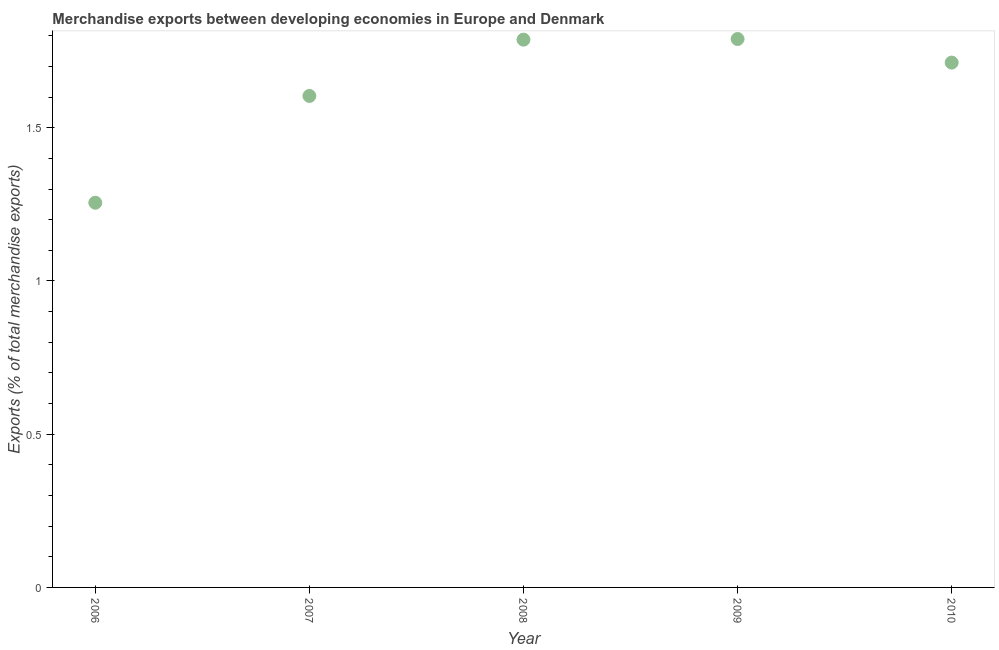What is the merchandise exports in 2010?
Provide a short and direct response. 1.71. Across all years, what is the maximum merchandise exports?
Offer a terse response. 1.79. Across all years, what is the minimum merchandise exports?
Provide a succinct answer. 1.26. In which year was the merchandise exports maximum?
Your answer should be compact. 2009. What is the sum of the merchandise exports?
Provide a succinct answer. 8.15. What is the difference between the merchandise exports in 2006 and 2008?
Provide a short and direct response. -0.53. What is the average merchandise exports per year?
Give a very brief answer. 1.63. What is the median merchandise exports?
Give a very brief answer. 1.71. Do a majority of the years between 2006 and 2007 (inclusive) have merchandise exports greater than 1.5 %?
Provide a succinct answer. No. What is the ratio of the merchandise exports in 2007 to that in 2010?
Offer a terse response. 0.94. Is the merchandise exports in 2006 less than that in 2010?
Your response must be concise. Yes. What is the difference between the highest and the second highest merchandise exports?
Ensure brevity in your answer.  0. What is the difference between the highest and the lowest merchandise exports?
Your answer should be very brief. 0.53. Does the merchandise exports monotonically increase over the years?
Provide a succinct answer. No. How many dotlines are there?
Keep it short and to the point. 1. How many years are there in the graph?
Provide a succinct answer. 5. Does the graph contain grids?
Make the answer very short. No. What is the title of the graph?
Provide a succinct answer. Merchandise exports between developing economies in Europe and Denmark. What is the label or title of the Y-axis?
Your answer should be compact. Exports (% of total merchandise exports). What is the Exports (% of total merchandise exports) in 2006?
Keep it short and to the point. 1.26. What is the Exports (% of total merchandise exports) in 2007?
Keep it short and to the point. 1.6. What is the Exports (% of total merchandise exports) in 2008?
Ensure brevity in your answer.  1.79. What is the Exports (% of total merchandise exports) in 2009?
Make the answer very short. 1.79. What is the Exports (% of total merchandise exports) in 2010?
Offer a very short reply. 1.71. What is the difference between the Exports (% of total merchandise exports) in 2006 and 2007?
Your answer should be very brief. -0.35. What is the difference between the Exports (% of total merchandise exports) in 2006 and 2008?
Your response must be concise. -0.53. What is the difference between the Exports (% of total merchandise exports) in 2006 and 2009?
Ensure brevity in your answer.  -0.53. What is the difference between the Exports (% of total merchandise exports) in 2006 and 2010?
Your answer should be compact. -0.46. What is the difference between the Exports (% of total merchandise exports) in 2007 and 2008?
Ensure brevity in your answer.  -0.18. What is the difference between the Exports (% of total merchandise exports) in 2007 and 2009?
Provide a short and direct response. -0.19. What is the difference between the Exports (% of total merchandise exports) in 2007 and 2010?
Keep it short and to the point. -0.11. What is the difference between the Exports (% of total merchandise exports) in 2008 and 2009?
Provide a succinct answer. -0. What is the difference between the Exports (% of total merchandise exports) in 2008 and 2010?
Offer a terse response. 0.07. What is the difference between the Exports (% of total merchandise exports) in 2009 and 2010?
Provide a short and direct response. 0.08. What is the ratio of the Exports (% of total merchandise exports) in 2006 to that in 2007?
Your answer should be compact. 0.78. What is the ratio of the Exports (% of total merchandise exports) in 2006 to that in 2008?
Provide a short and direct response. 0.7. What is the ratio of the Exports (% of total merchandise exports) in 2006 to that in 2009?
Give a very brief answer. 0.7. What is the ratio of the Exports (% of total merchandise exports) in 2006 to that in 2010?
Make the answer very short. 0.73. What is the ratio of the Exports (% of total merchandise exports) in 2007 to that in 2008?
Give a very brief answer. 0.9. What is the ratio of the Exports (% of total merchandise exports) in 2007 to that in 2009?
Keep it short and to the point. 0.9. What is the ratio of the Exports (% of total merchandise exports) in 2007 to that in 2010?
Offer a very short reply. 0.94. What is the ratio of the Exports (% of total merchandise exports) in 2008 to that in 2009?
Your answer should be compact. 1. What is the ratio of the Exports (% of total merchandise exports) in 2008 to that in 2010?
Make the answer very short. 1.04. What is the ratio of the Exports (% of total merchandise exports) in 2009 to that in 2010?
Offer a terse response. 1.04. 